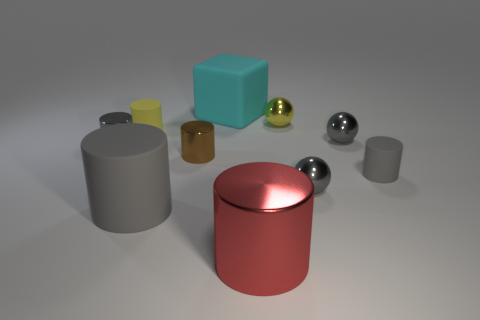There is a shiny cylinder on the left side of the small yellow object that is to the left of the large gray rubber object on the left side of the cyan thing; what is its color?
Your response must be concise. Gray. Does the small yellow ball have the same material as the big cube?
Offer a very short reply. No. Is the yellow shiny thing the same shape as the large cyan object?
Your response must be concise. No. Are there an equal number of big cyan things to the left of the yellow sphere and large objects behind the big red thing?
Give a very brief answer. No. The other big object that is the same material as the large cyan thing is what color?
Offer a terse response. Gray. What number of other tiny brown things have the same material as the small brown thing?
Offer a terse response. 0. Do the matte cylinder that is on the right side of the cyan thing and the rubber cube have the same color?
Provide a succinct answer. No. How many other large objects are the same shape as the red thing?
Offer a terse response. 1. Are there the same number of tiny gray metallic objects that are to the left of the cyan rubber block and large blue cylinders?
Ensure brevity in your answer.  No. What color is the metal cylinder that is the same size as the brown thing?
Your response must be concise. Gray. 